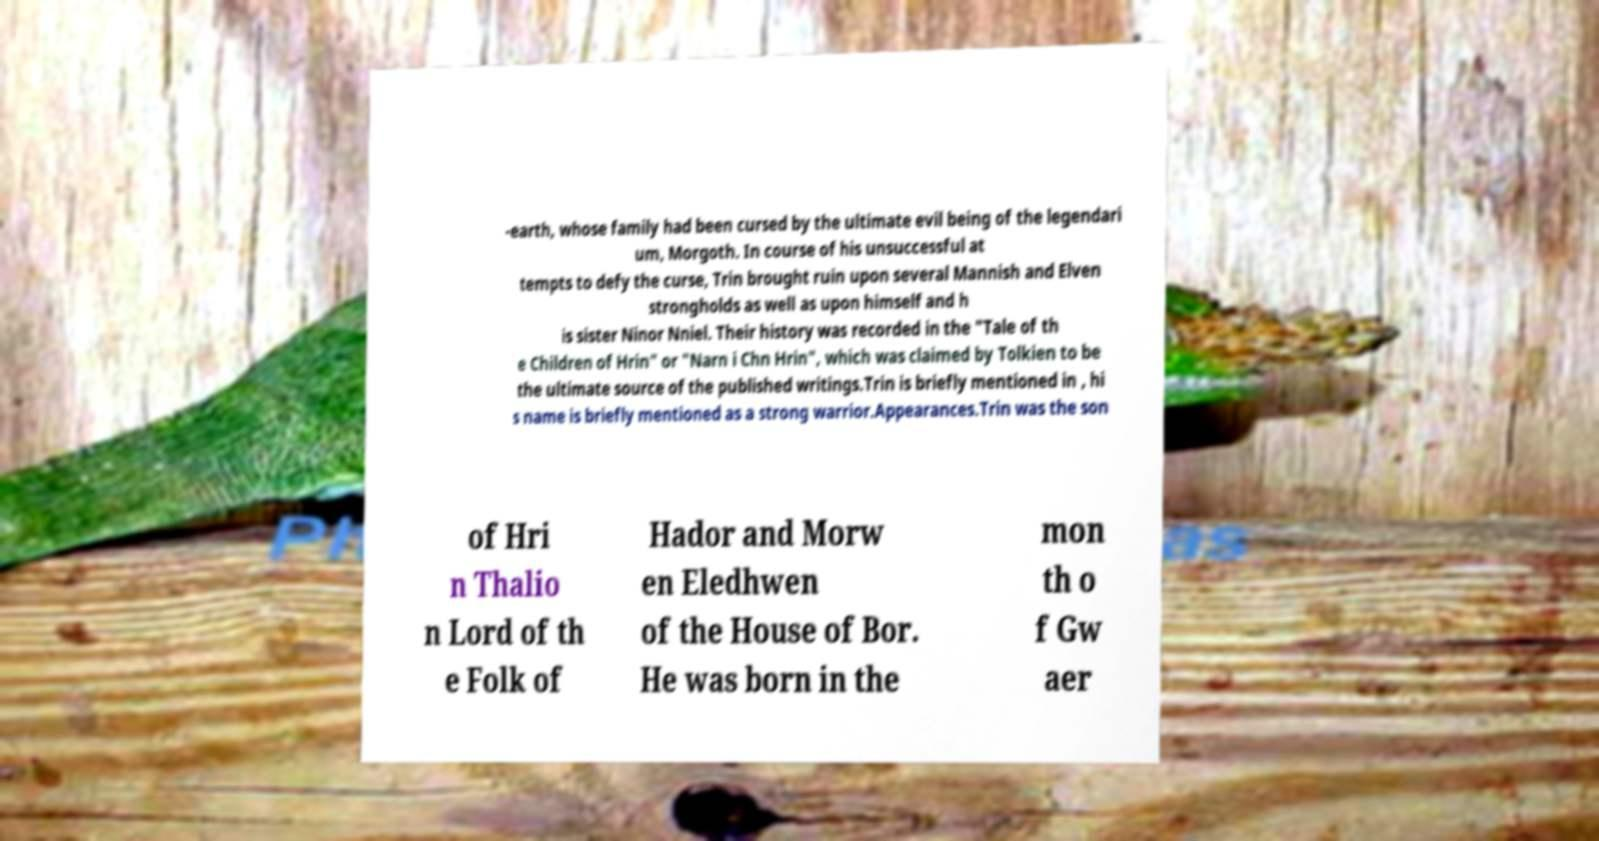Could you assist in decoding the text presented in this image and type it out clearly? -earth, whose family had been cursed by the ultimate evil being of the legendari um, Morgoth. In course of his unsuccessful at tempts to defy the curse, Trin brought ruin upon several Mannish and Elven strongholds as well as upon himself and h is sister Ninor Nniel. Their history was recorded in the "Tale of th e Children of Hrin" or "Narn i Chn Hrin", which was claimed by Tolkien to be the ultimate source of the published writings.Trin is briefly mentioned in , hi s name is briefly mentioned as a strong warrior.Appearances.Trin was the son of Hri n Thalio n Lord of th e Folk of Hador and Morw en Eledhwen of the House of Bor. He was born in the mon th o f Gw aer 